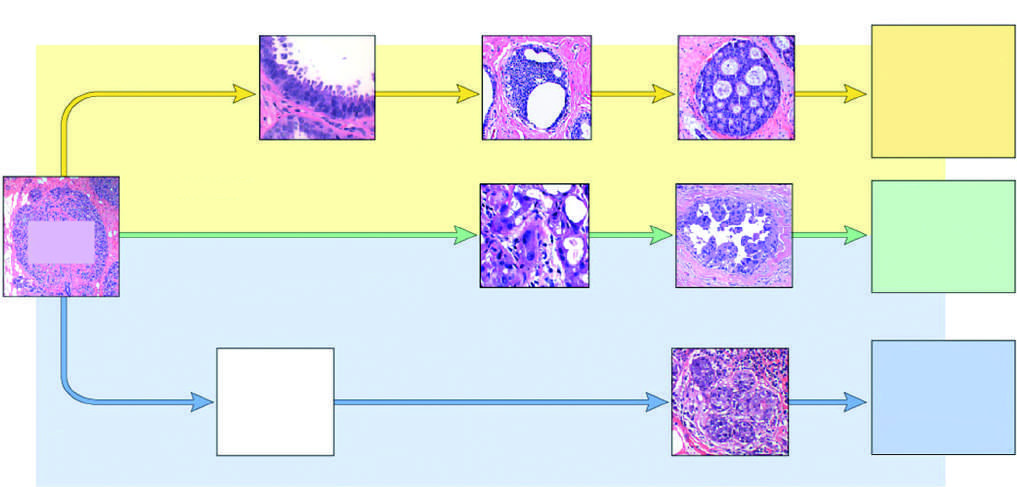what is negative for er and her2 (triple negative)?
Answer the question using a single word or phrase. The least common but molecularly most distinctive type of breast cancer 